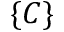Convert formula to latex. <formula><loc_0><loc_0><loc_500><loc_500>\{ C \}</formula> 